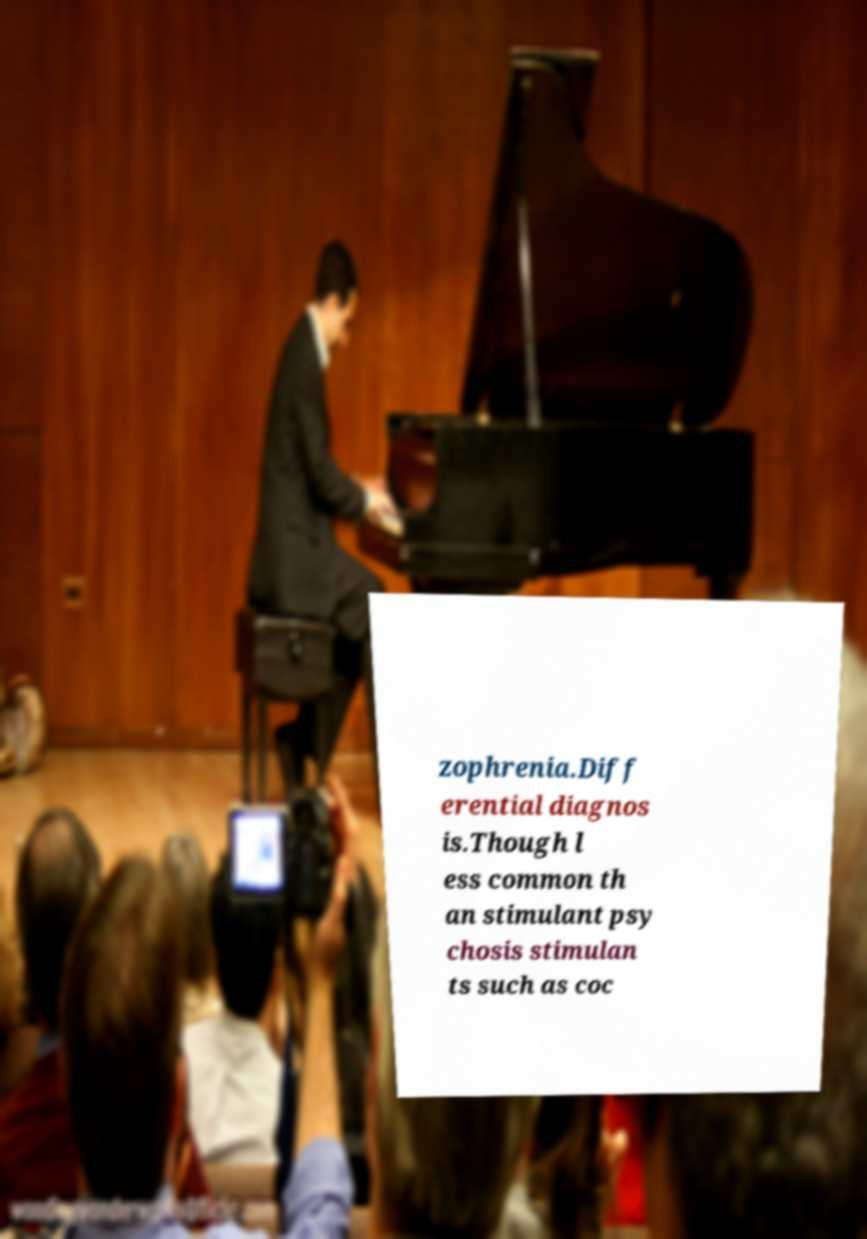What messages or text are displayed in this image? I need them in a readable, typed format. zophrenia.Diff erential diagnos is.Though l ess common th an stimulant psy chosis stimulan ts such as coc 